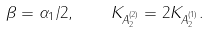<formula> <loc_0><loc_0><loc_500><loc_500>\beta = \alpha _ { 1 } / 2 , \quad K _ { A _ { 2 } ^ { ( 2 ) } } = 2 K _ { A _ { 2 } ^ { ( 1 ) } } .</formula> 